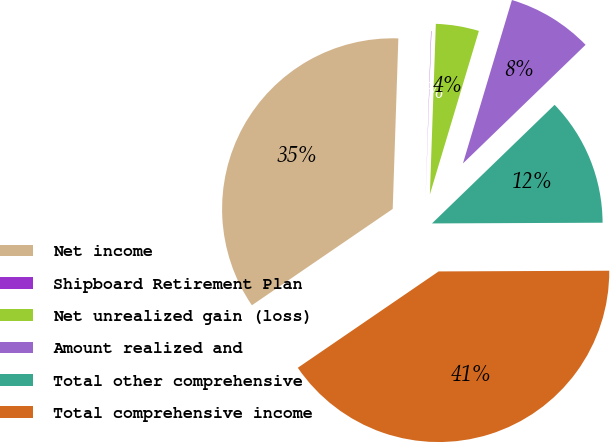<chart> <loc_0><loc_0><loc_500><loc_500><pie_chart><fcel>Net income<fcel>Shipboard Retirement Plan<fcel>Net unrealized gain (loss)<fcel>Amount realized and<fcel>Total other comprehensive<fcel>Total comprehensive income<nl><fcel>35.08%<fcel>0.03%<fcel>4.08%<fcel>8.13%<fcel>12.17%<fcel>40.52%<nl></chart> 